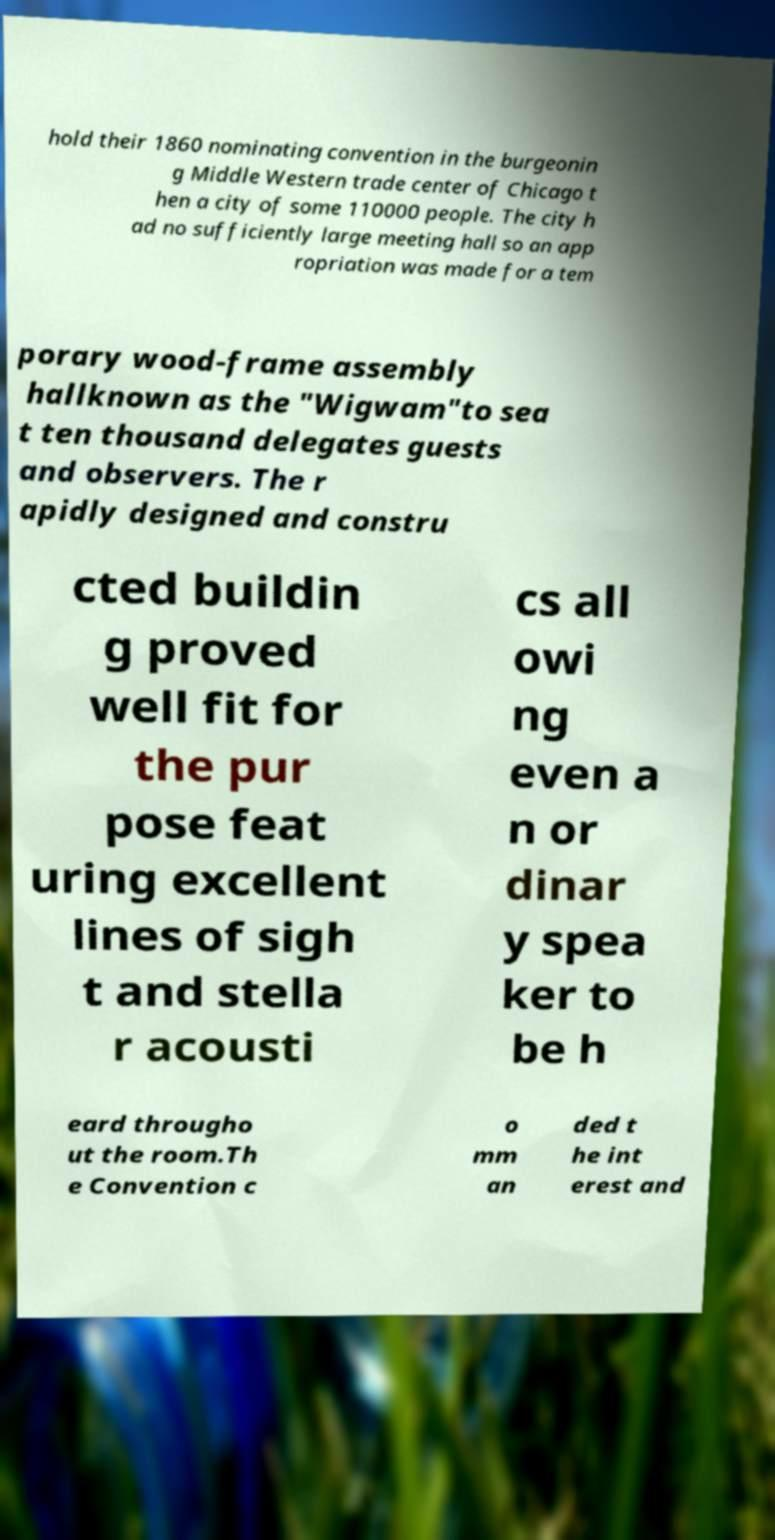There's text embedded in this image that I need extracted. Can you transcribe it verbatim? hold their 1860 nominating convention in the burgeonin g Middle Western trade center of Chicago t hen a city of some 110000 people. The city h ad no sufficiently large meeting hall so an app ropriation was made for a tem porary wood-frame assembly hallknown as the "Wigwam"to sea t ten thousand delegates guests and observers. The r apidly designed and constru cted buildin g proved well fit for the pur pose feat uring excellent lines of sigh t and stella r acousti cs all owi ng even a n or dinar y spea ker to be h eard througho ut the room.Th e Convention c o mm an ded t he int erest and 